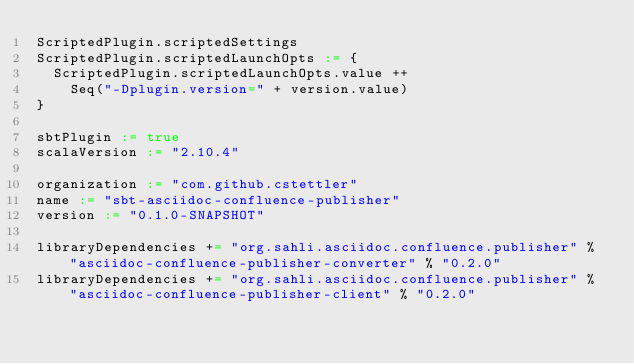Convert code to text. <code><loc_0><loc_0><loc_500><loc_500><_Scala_>ScriptedPlugin.scriptedSettings
ScriptedPlugin.scriptedLaunchOpts := {
  ScriptedPlugin.scriptedLaunchOpts.value ++
    Seq("-Dplugin.version=" + version.value)
}

sbtPlugin := true
scalaVersion := "2.10.4"

organization := "com.github.cstettler"
name := "sbt-asciidoc-confluence-publisher"
version := "0.1.0-SNAPSHOT"

libraryDependencies += "org.sahli.asciidoc.confluence.publisher" % "asciidoc-confluence-publisher-converter" % "0.2.0"
libraryDependencies += "org.sahli.asciidoc.confluence.publisher" % "asciidoc-confluence-publisher-client" % "0.2.0"
</code> 